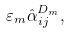Convert formula to latex. <formula><loc_0><loc_0><loc_500><loc_500>\varepsilon _ { m } \hat { \alpha } _ { i j } ^ { D _ { m } } ,</formula> 